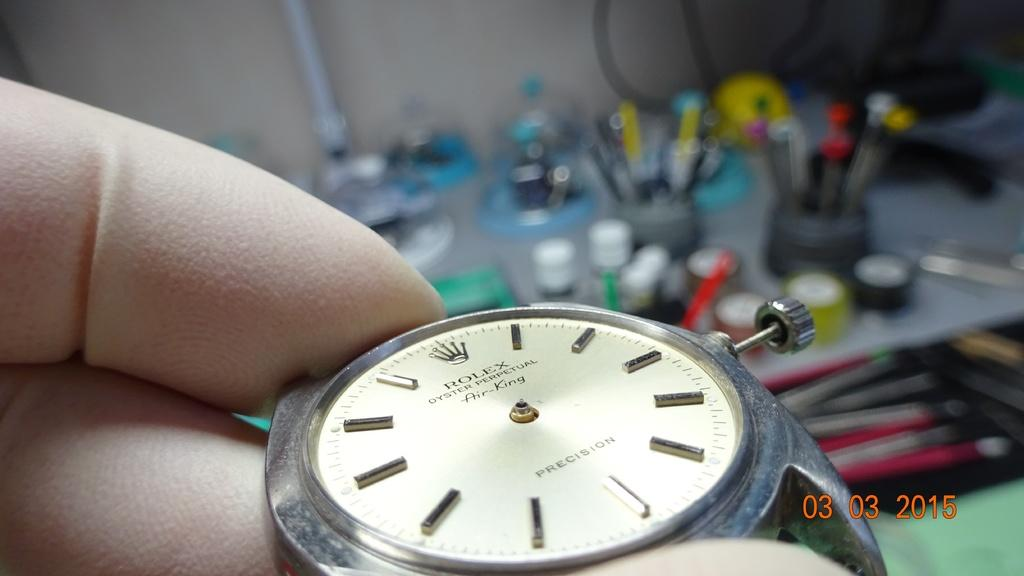<image>
Create a compact narrative representing the image presented. A photo of a watch face was taken on 03/03/2015. 